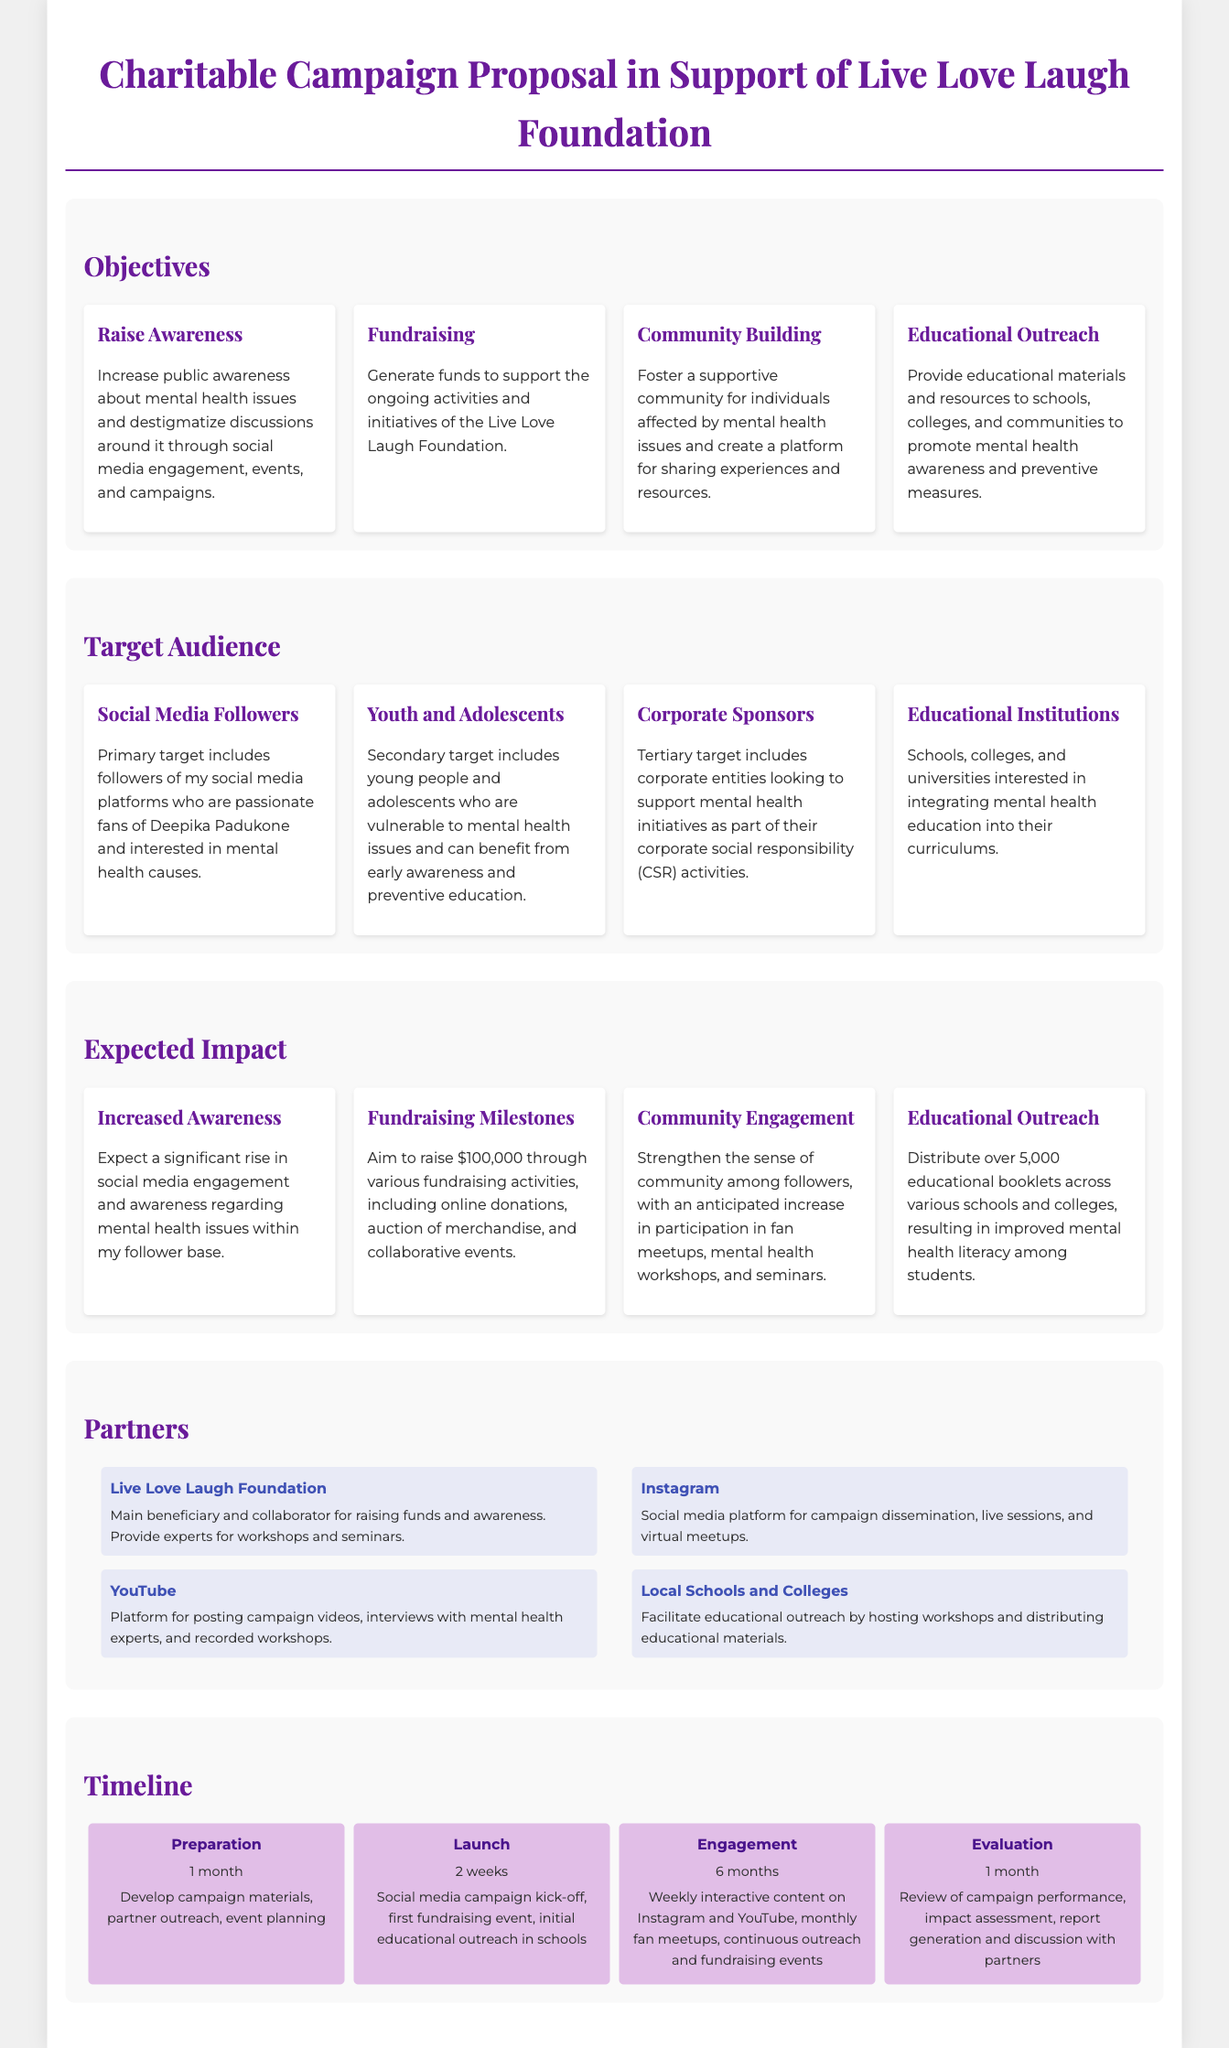What is the main beneficiary of the campaign? The main beneficiary mentioned in the document is the Live Love Laugh Foundation, which collaborates for raising funds and awareness.
Answer: Live Love Laugh Foundation How much money aims to be raised through fundraising? The document states a goal of $100,000 in fundraising activities through various initiatives.
Answer: $100,000 Who is the primary target audience for the campaign? The primary target identified in the document consists of followers of the social media platforms who are passionate fans of Deepika Padukone.
Answer: Social Media Followers What is the timeline duration for the engagement phase? The document outlines that the engagement phase of the campaign is set for a duration of 6 months.
Answer: 6 months What type of educational outreach does the campaign intend to provide? The campaign aims to distribute educational materials and conduct workshops in schools and colleges to promote mental health awareness.
Answer: Educational materials and workshops What is one of the objectives listed in the proposal? The proposal includes multiple objectives, one of which is to raise awareness about mental health issues and destigmatize discussions surrounding them.
Answer: Raise Awareness Which social media platform is mentioned as a partner for campaign dissemination? The document mentions Instagram as a partner for disseminating the campaign, conducting live sessions, and virtual meetups.
Answer: Instagram What is the expected outcome regarding community engagement? An anticipated outcome includes strengthening the sense of community among followers, with increased participation in various activities.
Answer: Strengthen community engagement 